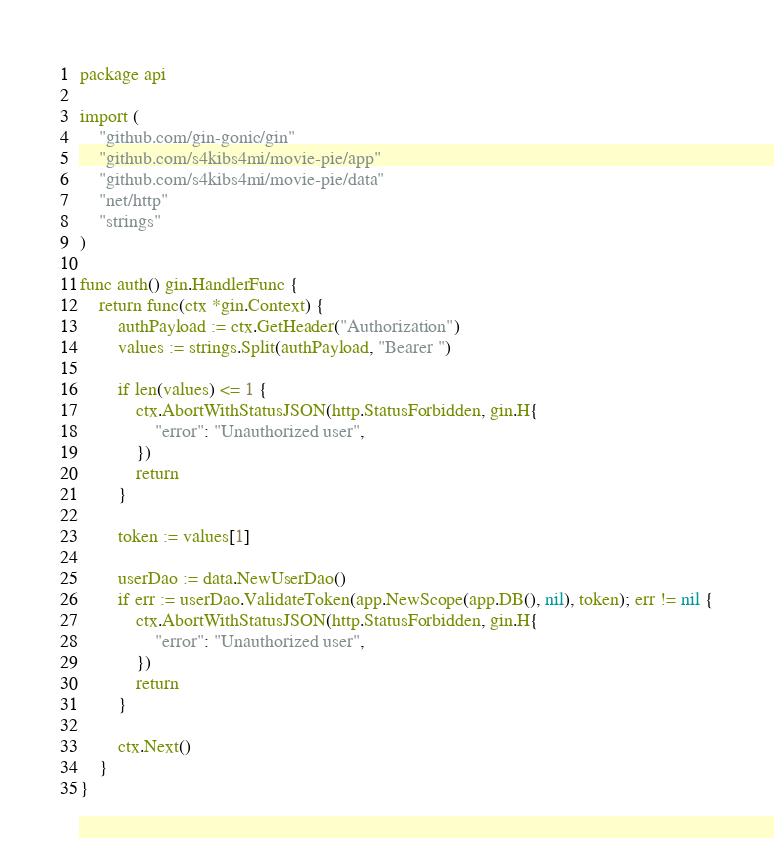<code> <loc_0><loc_0><loc_500><loc_500><_Go_>package api

import (
	"github.com/gin-gonic/gin"
	"github.com/s4kibs4mi/movie-pie/app"
	"github.com/s4kibs4mi/movie-pie/data"
	"net/http"
	"strings"
)

func auth() gin.HandlerFunc {
	return func(ctx *gin.Context) {
		authPayload := ctx.GetHeader("Authorization")
		values := strings.Split(authPayload, "Bearer ")

		if len(values) <= 1 {
			ctx.AbortWithStatusJSON(http.StatusForbidden, gin.H{
				"error": "Unauthorized user",
			})
			return
		}

		token := values[1]

		userDao := data.NewUserDao()
		if err := userDao.ValidateToken(app.NewScope(app.DB(), nil), token); err != nil {
			ctx.AbortWithStatusJSON(http.StatusForbidden, gin.H{
				"error": "Unauthorized user",
			})
			return
		}

		ctx.Next()
	}
}
</code> 